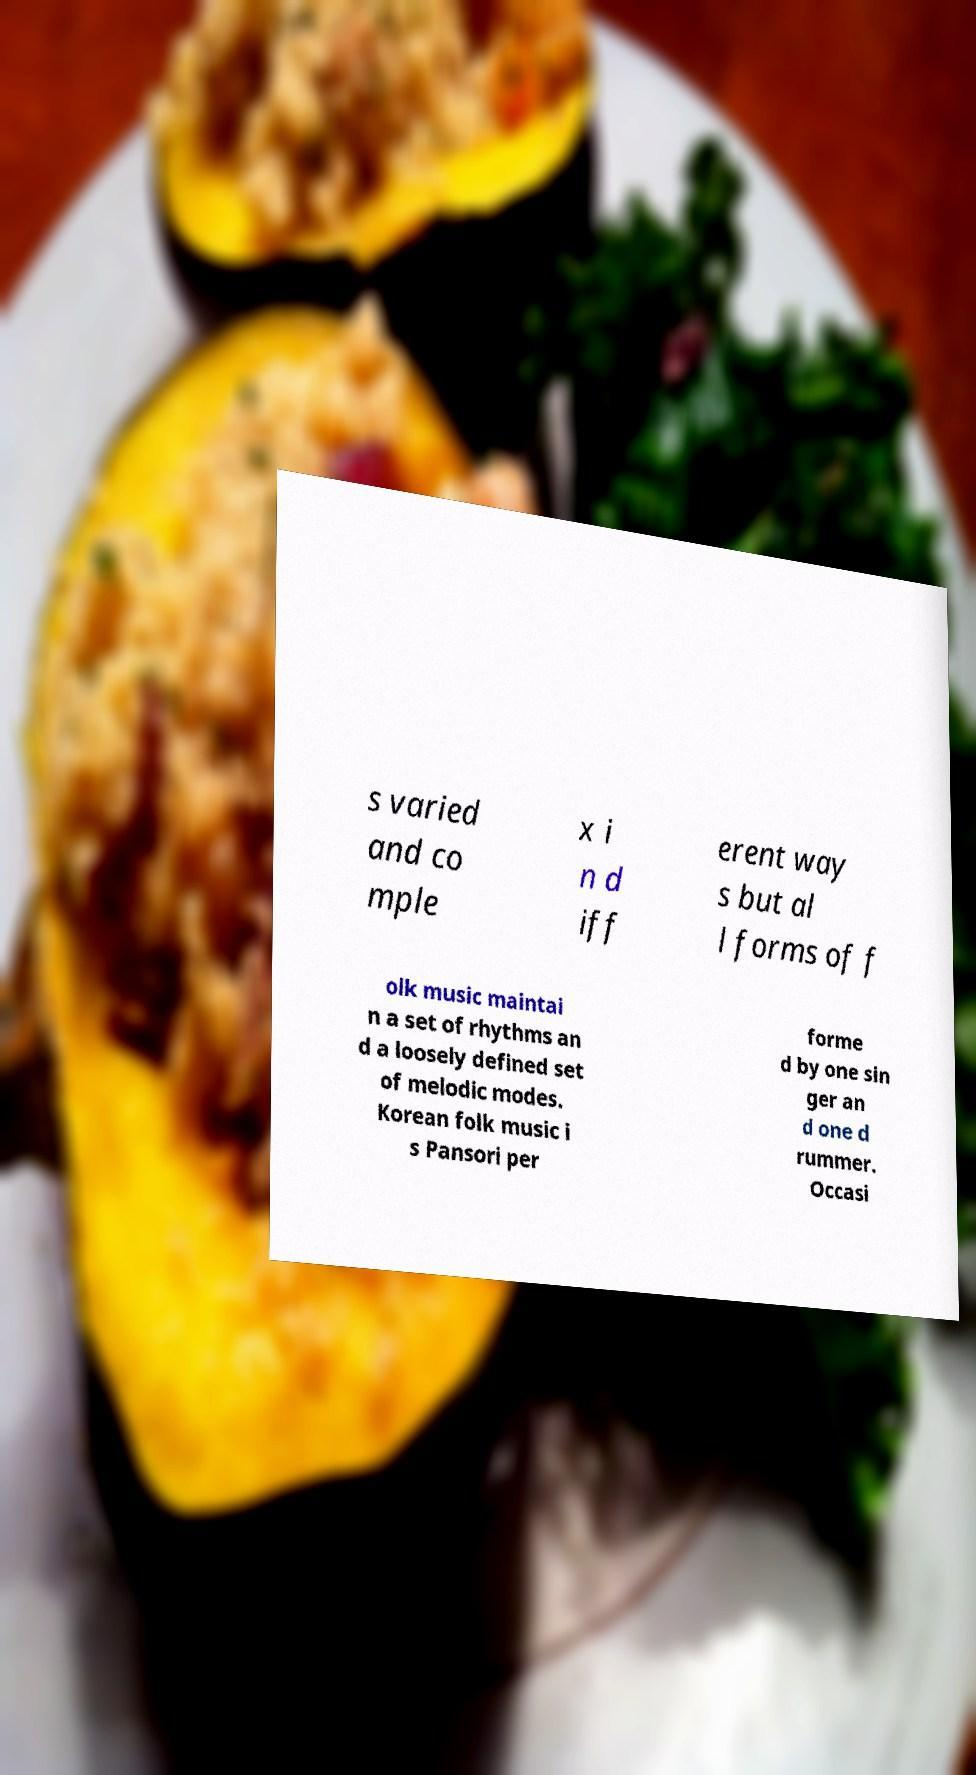There's text embedded in this image that I need extracted. Can you transcribe it verbatim? s varied and co mple x i n d iff erent way s but al l forms of f olk music maintai n a set of rhythms an d a loosely defined set of melodic modes. Korean folk music i s Pansori per forme d by one sin ger an d one d rummer. Occasi 